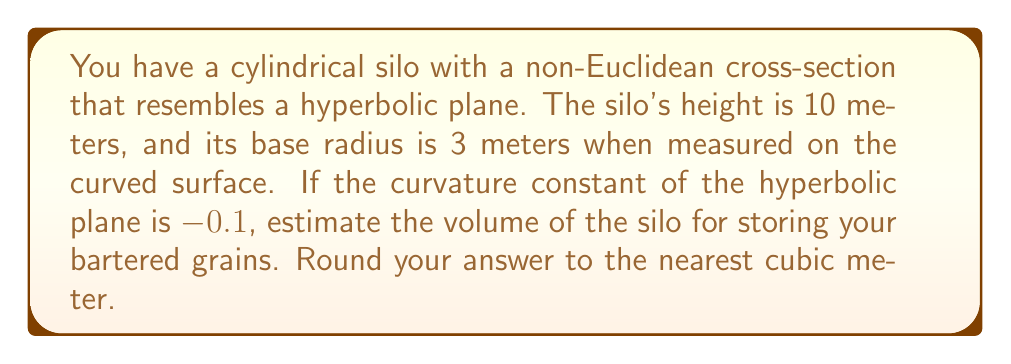Teach me how to tackle this problem. To estimate the volume of the silo with a non-Euclidean cross-section, we'll follow these steps:

1) In hyperbolic geometry, the area of a circle with radius $r$ is given by:

   $$A = 4\pi \sinh^2(\sqrt{-k}r/2) / k$$

   where $k$ is the curvature constant.

2) Substituting our values: $r = 3$ and $k = -0.1$:

   $$A = 4\pi \sinh^2(\sqrt{0.1} \cdot 3/2) / (-0.1)$$

3) Calculate:
   $$A = 4\pi \sinh^2(0.474) / (-0.1)$$
   $$A = 4\pi \cdot 0.25^2 / (-0.1)$$
   $$A = 4\pi \cdot 0.0625 / (-0.1)$$
   $$A = 0.25\pi / (-0.1)$$
   $$A \approx 7.85 \text{ square meters}$$

4) The volume of a cylinder is given by $V = A \cdot h$, where $A$ is the area of the base and $h$ is the height.

5) Therefore, the volume of our silo is:

   $$V = 7.85 \cdot 10 = 78.5 \text{ cubic meters}$$

6) Rounding to the nearest cubic meter:

   $$V \approx 79 \text{ cubic meters}$$
Answer: 79 cubic meters 